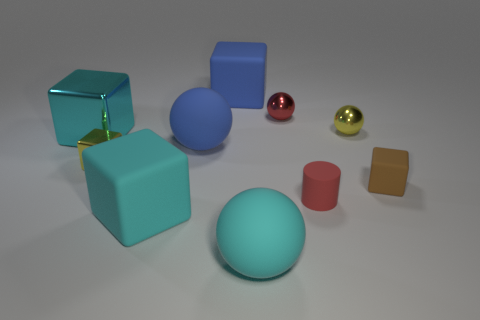There is a cyan rubber object that is the same size as the cyan rubber cube; what is its shape?
Give a very brief answer. Sphere. Does the tiny brown rubber thing have the same shape as the large metallic object?
Give a very brief answer. Yes. How many other brown objects are the same shape as the brown rubber thing?
Provide a short and direct response. 0. What number of big matte balls are to the right of the red metallic ball?
Your response must be concise. 0. There is a large rubber block in front of the red sphere; is it the same color as the big metallic cube?
Your answer should be compact. Yes. How many yellow objects are the same size as the brown matte block?
Provide a short and direct response. 2. What shape is the red object that is the same material as the yellow block?
Provide a succinct answer. Sphere. Is there a metal sphere that has the same color as the small cylinder?
Offer a very short reply. Yes. What material is the cyan ball?
Make the answer very short. Rubber. What number of things are tiny metal blocks or brown cylinders?
Provide a short and direct response. 1. 